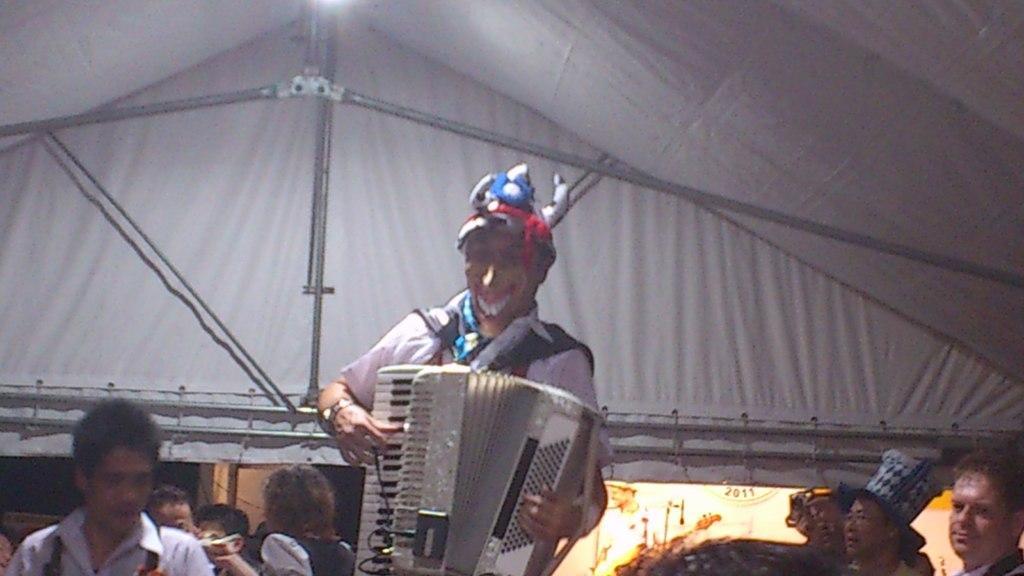Please provide a concise description of this image. In this image, there is a person wearing clothes and playing a musical instrument. There are some persons in the bottom left and in the bottom right of the image. 